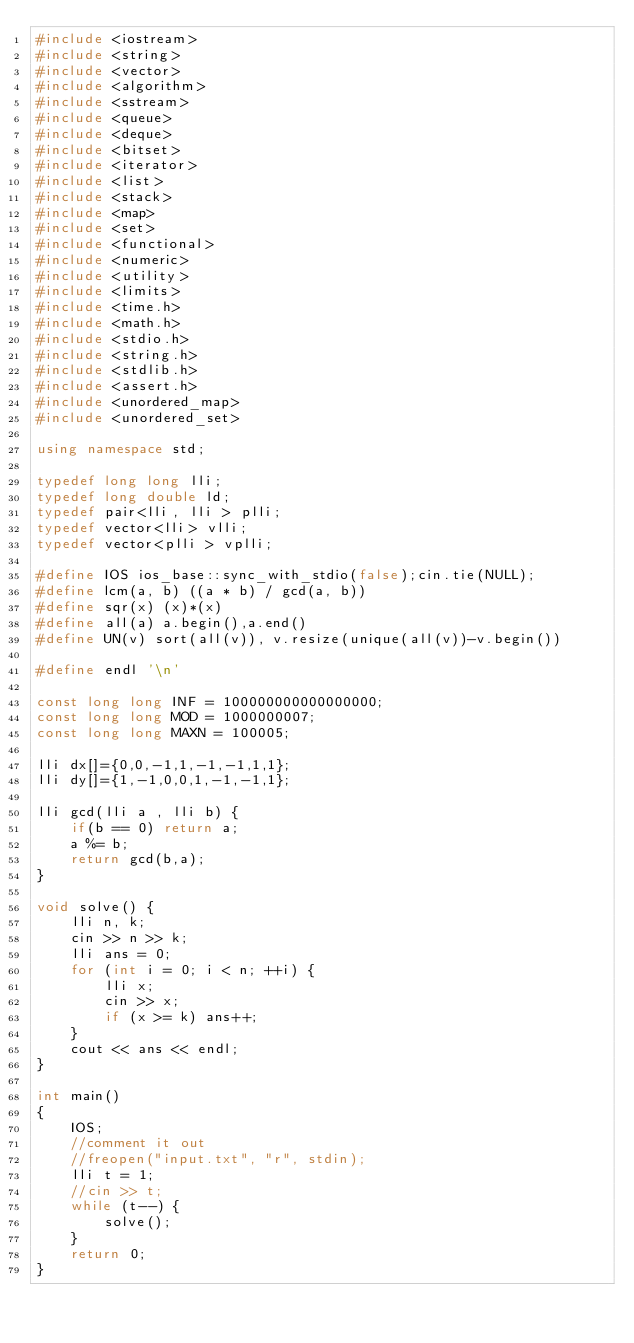<code> <loc_0><loc_0><loc_500><loc_500><_C++_>#include <iostream>
#include <string>
#include <vector>
#include <algorithm>
#include <sstream>
#include <queue>
#include <deque>
#include <bitset>
#include <iterator>
#include <list>
#include <stack>
#include <map>
#include <set>
#include <functional>
#include <numeric>
#include <utility>
#include <limits>
#include <time.h>
#include <math.h>
#include <stdio.h>
#include <string.h>
#include <stdlib.h>
#include <assert.h>
#include <unordered_map>
#include <unordered_set>

using namespace std;

typedef long long lli;
typedef long double ld;
typedef pair<lli, lli > plli;
typedef vector<lli> vlli;
typedef vector<plli > vplli;

#define IOS ios_base::sync_with_stdio(false);cin.tie(NULL);
#define lcm(a, b) ((a * b) / gcd(a, b))
#define sqr(x) (x)*(x)
#define all(a) a.begin(),a.end()
#define UN(v) sort(all(v)), v.resize(unique(all(v))-v.begin())

#define endl '\n'

const long long INF = 100000000000000000;
const long long MOD = 1000000007;
const long long MAXN = 100005;

lli dx[]={0,0,-1,1,-1,-1,1,1};
lli dy[]={1,-1,0,0,1,-1,-1,1};

lli gcd(lli a , lli b) {
    if(b == 0) return a;
    a %= b;
    return gcd(b,a);
}

void solve() {
    lli n, k;
    cin >> n >> k;
    lli ans = 0;
    for (int i = 0; i < n; ++i) {
        lli x;
        cin >> x;
        if (x >= k) ans++;
    }
    cout << ans << endl;
}

int main()
{
    IOS;
    //comment it out
    //freopen("input.txt", "r", stdin);
    lli t = 1;
    //cin >> t;
    while (t--) {
        solve();
    }
    return 0;
}
</code> 